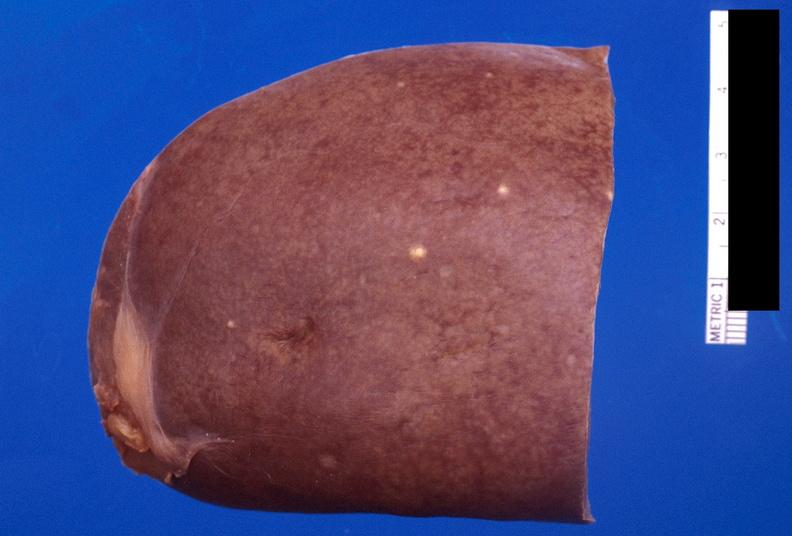s intestine present?
Answer the question using a single word or phrase. No 